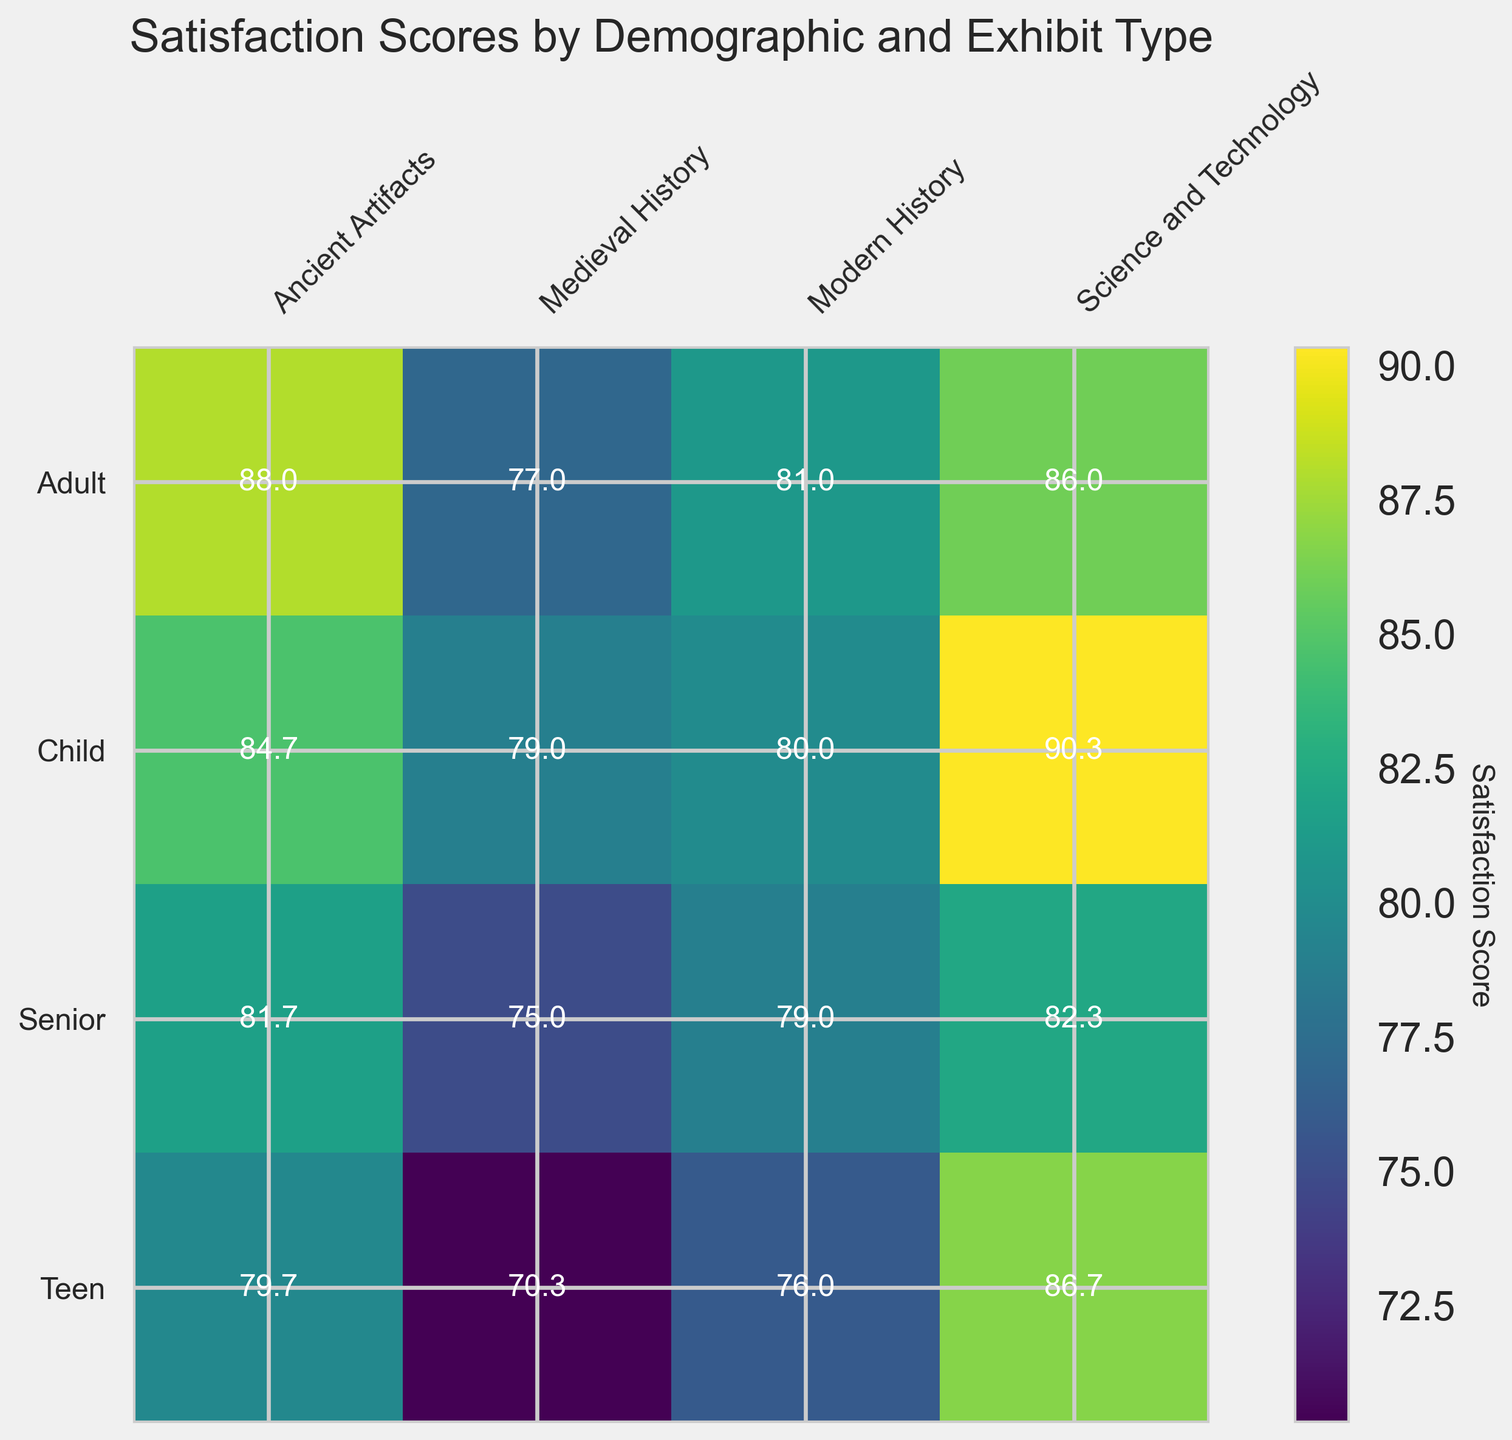What is the average satisfaction score for the "Modern History" exhibit across all demographics? The satisfaction scores for "Modern History" are 82 (Child), 76 (Teen), 81 (Adult), and 79 (Senior). Summing these gives 318. Dividing by 4 gives an average of 79.5.
Answer: 79.5 Which demographic group gave the highest satisfaction score for the "Science and Technology" exhibit? Reviewing the scores for "Science and Technology": Child (90), Teen (88), Adult (86), and Senior (84), the highest score is from the Child demographic.
Answer: Child How much higher, on average, is the satisfaction score for the "Science and Technology" exhibit compared to the "Medieval History" exhibit? Calculating the average score: Science and Technology (Child 90, Teen 88, Adult 86, Senior 84) is 87. Medieval History (Child 80, Teen 70, Adult 77, Senior 75) is 75.5. The difference is 87 - 75.5 = 11.5.
Answer: 11.5 Which exhibit has the most consistent satisfaction scores across demographics, defined by the smallest range between the highest and lowest scores? The ranges are "Ancient Artifacts" (89-80=9), "Medieval History" (80-69=11), "Modern History" (82-76=6), and "Science and Technology" (90-84=6). The smallest range is shared by "Modern History" and "Science and Technology" at 6.
Answer: Modern History, Science and Technology For the Adult demographic, which exhibit type shows the lowest satisfaction score and what is this score? Looking at the Adult demographic: Ancient Artifacts (88), Medieval History (77), Modern History (80), and Science and Technology (86). The lowest score is for Medieval History at 77.
Answer: Medieval History, 77 How does the satisfaction score for "Ancient Artifacts" compare between Children and Seniors? Children gave a satisfaction score of 85, while Seniors gave it 82. Therefore, Children gave it a higher score by 3 points.
Answer: Children gave a higher score by 3 points What is the difference between the highest and the lowest satisfaction scores in the entire heatmap? The highest score in the heatmap is 90 (Science and Technology, Child), and the lowest is 69 (Medieval History, Teen). The difference is 90 - 69 = 21.
Answer: 21 Which demographic group shows the smallest variation in satisfaction scores across all exhibit types? Review the score ranges: Child (90-78=12), Teen (88-69=19), Adult (88-77=11), and Senior (84-75=9). Seniors show the smallest variation with a range of 9.
Answer: Senior 